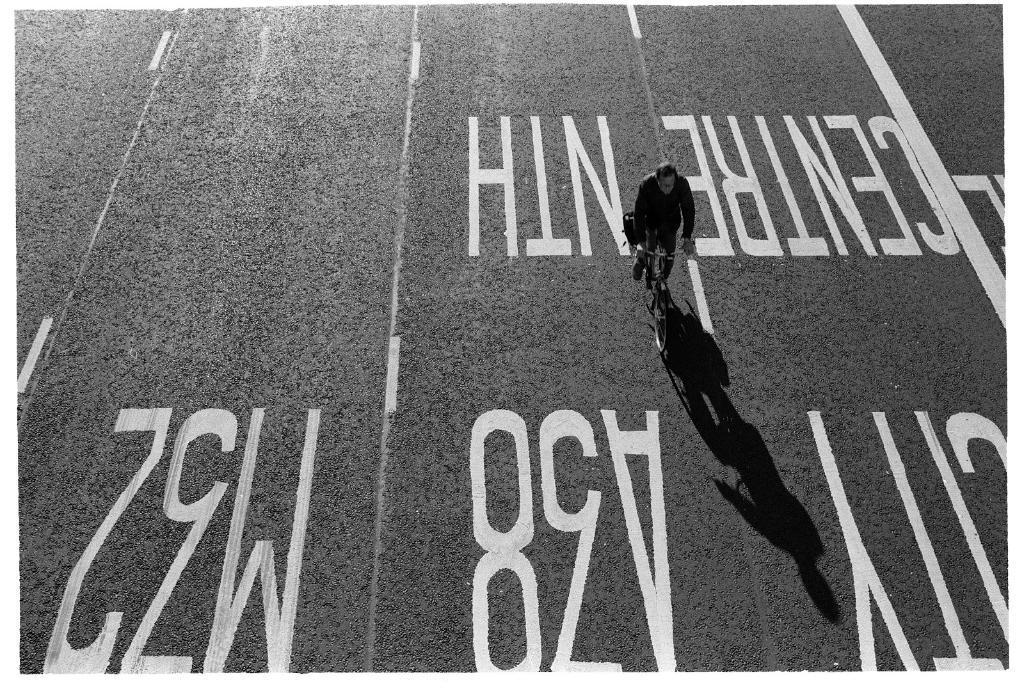<image>
Write a terse but informative summary of the picture. A man biking on a road in a lane labeled A38. 